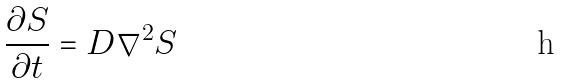<formula> <loc_0><loc_0><loc_500><loc_500>\frac { \partial S } { \partial t } = D \nabla ^ { 2 } S</formula> 